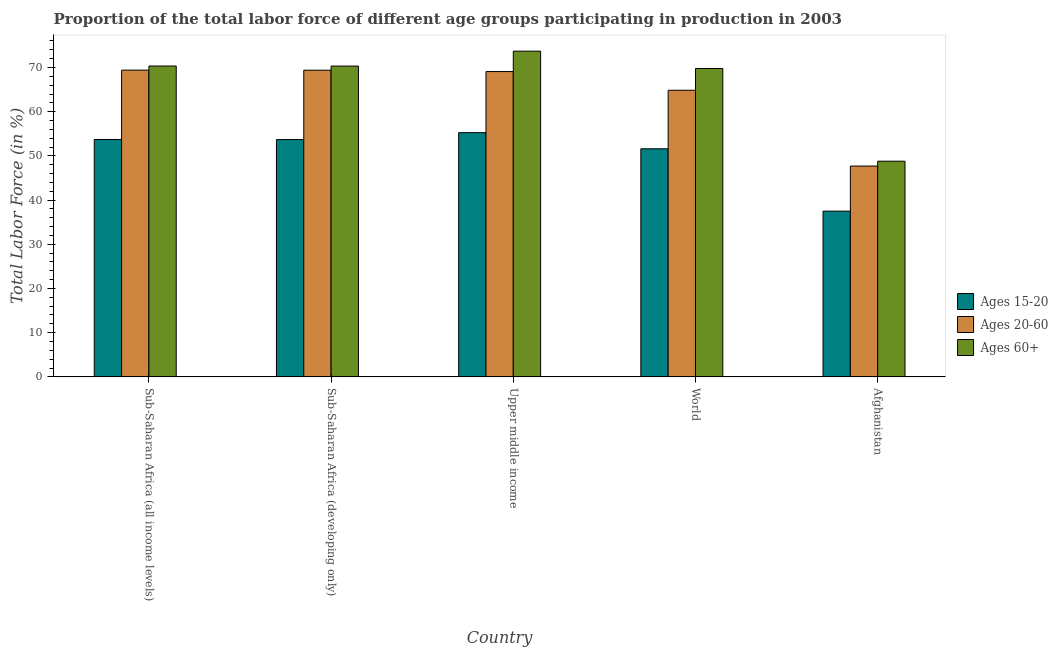How many groups of bars are there?
Your answer should be compact. 5. Are the number of bars on each tick of the X-axis equal?
Offer a very short reply. Yes. How many bars are there on the 5th tick from the left?
Ensure brevity in your answer.  3. What is the label of the 4th group of bars from the left?
Keep it short and to the point. World. In how many cases, is the number of bars for a given country not equal to the number of legend labels?
Provide a succinct answer. 0. What is the percentage of labor force within the age group 20-60 in Afghanistan?
Offer a very short reply. 47.7. Across all countries, what is the maximum percentage of labor force above age 60?
Make the answer very short. 73.7. Across all countries, what is the minimum percentage of labor force within the age group 20-60?
Ensure brevity in your answer.  47.7. In which country was the percentage of labor force within the age group 20-60 maximum?
Give a very brief answer. Sub-Saharan Africa (all income levels). In which country was the percentage of labor force within the age group 15-20 minimum?
Provide a short and direct response. Afghanistan. What is the total percentage of labor force within the age group 20-60 in the graph?
Your answer should be very brief. 320.43. What is the difference between the percentage of labor force within the age group 15-20 in Sub-Saharan Africa (developing only) and that in World?
Your answer should be very brief. 2.09. What is the difference between the percentage of labor force within the age group 20-60 in Sub-Saharan Africa (developing only) and the percentage of labor force above age 60 in Upper middle income?
Give a very brief answer. -4.31. What is the average percentage of labor force within the age group 20-60 per country?
Provide a succinct answer. 64.09. What is the difference between the percentage of labor force within the age group 15-20 and percentage of labor force above age 60 in World?
Keep it short and to the point. -18.17. In how many countries, is the percentage of labor force above age 60 greater than 58 %?
Keep it short and to the point. 4. What is the ratio of the percentage of labor force within the age group 15-20 in Afghanistan to that in World?
Keep it short and to the point. 0.73. Is the difference between the percentage of labor force above age 60 in Sub-Saharan Africa (developing only) and World greater than the difference between the percentage of labor force within the age group 15-20 in Sub-Saharan Africa (developing only) and World?
Your answer should be compact. No. What is the difference between the highest and the second highest percentage of labor force within the age group 20-60?
Make the answer very short. 0.01. What is the difference between the highest and the lowest percentage of labor force above age 60?
Offer a terse response. 24.9. In how many countries, is the percentage of labor force within the age group 20-60 greater than the average percentage of labor force within the age group 20-60 taken over all countries?
Offer a terse response. 4. Is the sum of the percentage of labor force within the age group 20-60 in Sub-Saharan Africa (all income levels) and Upper middle income greater than the maximum percentage of labor force within the age group 15-20 across all countries?
Provide a short and direct response. Yes. What does the 1st bar from the left in Afghanistan represents?
Make the answer very short. Ages 15-20. What does the 3rd bar from the right in Upper middle income represents?
Give a very brief answer. Ages 15-20. How many bars are there?
Make the answer very short. 15. How many countries are there in the graph?
Your answer should be compact. 5. What is the difference between two consecutive major ticks on the Y-axis?
Your answer should be very brief. 10. Does the graph contain grids?
Offer a very short reply. No. What is the title of the graph?
Provide a short and direct response. Proportion of the total labor force of different age groups participating in production in 2003. What is the Total Labor Force (in %) of Ages 15-20 in Sub-Saharan Africa (all income levels)?
Provide a succinct answer. 53.71. What is the Total Labor Force (in %) in Ages 20-60 in Sub-Saharan Africa (all income levels)?
Make the answer very short. 69.4. What is the Total Labor Force (in %) of Ages 60+ in Sub-Saharan Africa (all income levels)?
Give a very brief answer. 70.34. What is the Total Labor Force (in %) of Ages 15-20 in Sub-Saharan Africa (developing only)?
Offer a terse response. 53.69. What is the Total Labor Force (in %) in Ages 20-60 in Sub-Saharan Africa (developing only)?
Your answer should be very brief. 69.39. What is the Total Labor Force (in %) in Ages 60+ in Sub-Saharan Africa (developing only)?
Offer a terse response. 70.32. What is the Total Labor Force (in %) in Ages 15-20 in Upper middle income?
Provide a short and direct response. 55.26. What is the Total Labor Force (in %) in Ages 20-60 in Upper middle income?
Ensure brevity in your answer.  69.08. What is the Total Labor Force (in %) of Ages 60+ in Upper middle income?
Ensure brevity in your answer.  73.7. What is the Total Labor Force (in %) of Ages 15-20 in World?
Offer a terse response. 51.61. What is the Total Labor Force (in %) in Ages 20-60 in World?
Offer a very short reply. 64.85. What is the Total Labor Force (in %) of Ages 60+ in World?
Provide a succinct answer. 69.78. What is the Total Labor Force (in %) in Ages 15-20 in Afghanistan?
Offer a very short reply. 37.5. What is the Total Labor Force (in %) in Ages 20-60 in Afghanistan?
Your answer should be very brief. 47.7. What is the Total Labor Force (in %) in Ages 60+ in Afghanistan?
Your response must be concise. 48.8. Across all countries, what is the maximum Total Labor Force (in %) of Ages 15-20?
Make the answer very short. 55.26. Across all countries, what is the maximum Total Labor Force (in %) of Ages 20-60?
Provide a succinct answer. 69.4. Across all countries, what is the maximum Total Labor Force (in %) in Ages 60+?
Give a very brief answer. 73.7. Across all countries, what is the minimum Total Labor Force (in %) in Ages 15-20?
Offer a terse response. 37.5. Across all countries, what is the minimum Total Labor Force (in %) of Ages 20-60?
Give a very brief answer. 47.7. Across all countries, what is the minimum Total Labor Force (in %) of Ages 60+?
Provide a short and direct response. 48.8. What is the total Total Labor Force (in %) in Ages 15-20 in the graph?
Your answer should be very brief. 251.76. What is the total Total Labor Force (in %) of Ages 20-60 in the graph?
Your answer should be compact. 320.43. What is the total Total Labor Force (in %) in Ages 60+ in the graph?
Keep it short and to the point. 332.94. What is the difference between the Total Labor Force (in %) in Ages 15-20 in Sub-Saharan Africa (all income levels) and that in Sub-Saharan Africa (developing only)?
Provide a short and direct response. 0.02. What is the difference between the Total Labor Force (in %) in Ages 20-60 in Sub-Saharan Africa (all income levels) and that in Sub-Saharan Africa (developing only)?
Give a very brief answer. 0.01. What is the difference between the Total Labor Force (in %) of Ages 60+ in Sub-Saharan Africa (all income levels) and that in Sub-Saharan Africa (developing only)?
Make the answer very short. 0.02. What is the difference between the Total Labor Force (in %) in Ages 15-20 in Sub-Saharan Africa (all income levels) and that in Upper middle income?
Provide a succinct answer. -1.55. What is the difference between the Total Labor Force (in %) in Ages 20-60 in Sub-Saharan Africa (all income levels) and that in Upper middle income?
Ensure brevity in your answer.  0.32. What is the difference between the Total Labor Force (in %) of Ages 60+ in Sub-Saharan Africa (all income levels) and that in Upper middle income?
Give a very brief answer. -3.36. What is the difference between the Total Labor Force (in %) in Ages 15-20 in Sub-Saharan Africa (all income levels) and that in World?
Keep it short and to the point. 2.1. What is the difference between the Total Labor Force (in %) in Ages 20-60 in Sub-Saharan Africa (all income levels) and that in World?
Ensure brevity in your answer.  4.55. What is the difference between the Total Labor Force (in %) in Ages 60+ in Sub-Saharan Africa (all income levels) and that in World?
Offer a terse response. 0.56. What is the difference between the Total Labor Force (in %) of Ages 15-20 in Sub-Saharan Africa (all income levels) and that in Afghanistan?
Provide a succinct answer. 16.21. What is the difference between the Total Labor Force (in %) in Ages 20-60 in Sub-Saharan Africa (all income levels) and that in Afghanistan?
Ensure brevity in your answer.  21.7. What is the difference between the Total Labor Force (in %) of Ages 60+ in Sub-Saharan Africa (all income levels) and that in Afghanistan?
Provide a short and direct response. 21.54. What is the difference between the Total Labor Force (in %) of Ages 15-20 in Sub-Saharan Africa (developing only) and that in Upper middle income?
Make the answer very short. -1.56. What is the difference between the Total Labor Force (in %) in Ages 20-60 in Sub-Saharan Africa (developing only) and that in Upper middle income?
Your answer should be very brief. 0.31. What is the difference between the Total Labor Force (in %) of Ages 60+ in Sub-Saharan Africa (developing only) and that in Upper middle income?
Give a very brief answer. -3.37. What is the difference between the Total Labor Force (in %) in Ages 15-20 in Sub-Saharan Africa (developing only) and that in World?
Offer a very short reply. 2.09. What is the difference between the Total Labor Force (in %) of Ages 20-60 in Sub-Saharan Africa (developing only) and that in World?
Give a very brief answer. 4.54. What is the difference between the Total Labor Force (in %) in Ages 60+ in Sub-Saharan Africa (developing only) and that in World?
Make the answer very short. 0.54. What is the difference between the Total Labor Force (in %) in Ages 15-20 in Sub-Saharan Africa (developing only) and that in Afghanistan?
Ensure brevity in your answer.  16.19. What is the difference between the Total Labor Force (in %) in Ages 20-60 in Sub-Saharan Africa (developing only) and that in Afghanistan?
Ensure brevity in your answer.  21.69. What is the difference between the Total Labor Force (in %) of Ages 60+ in Sub-Saharan Africa (developing only) and that in Afghanistan?
Give a very brief answer. 21.52. What is the difference between the Total Labor Force (in %) in Ages 15-20 in Upper middle income and that in World?
Ensure brevity in your answer.  3.65. What is the difference between the Total Labor Force (in %) of Ages 20-60 in Upper middle income and that in World?
Your answer should be compact. 4.23. What is the difference between the Total Labor Force (in %) in Ages 60+ in Upper middle income and that in World?
Provide a short and direct response. 3.92. What is the difference between the Total Labor Force (in %) in Ages 15-20 in Upper middle income and that in Afghanistan?
Give a very brief answer. 17.76. What is the difference between the Total Labor Force (in %) of Ages 20-60 in Upper middle income and that in Afghanistan?
Provide a succinct answer. 21.38. What is the difference between the Total Labor Force (in %) of Ages 60+ in Upper middle income and that in Afghanistan?
Provide a short and direct response. 24.9. What is the difference between the Total Labor Force (in %) of Ages 15-20 in World and that in Afghanistan?
Ensure brevity in your answer.  14.11. What is the difference between the Total Labor Force (in %) of Ages 20-60 in World and that in Afghanistan?
Keep it short and to the point. 17.15. What is the difference between the Total Labor Force (in %) of Ages 60+ in World and that in Afghanistan?
Offer a terse response. 20.98. What is the difference between the Total Labor Force (in %) of Ages 15-20 in Sub-Saharan Africa (all income levels) and the Total Labor Force (in %) of Ages 20-60 in Sub-Saharan Africa (developing only)?
Ensure brevity in your answer.  -15.68. What is the difference between the Total Labor Force (in %) of Ages 15-20 in Sub-Saharan Africa (all income levels) and the Total Labor Force (in %) of Ages 60+ in Sub-Saharan Africa (developing only)?
Offer a terse response. -16.61. What is the difference between the Total Labor Force (in %) of Ages 20-60 in Sub-Saharan Africa (all income levels) and the Total Labor Force (in %) of Ages 60+ in Sub-Saharan Africa (developing only)?
Make the answer very short. -0.92. What is the difference between the Total Labor Force (in %) in Ages 15-20 in Sub-Saharan Africa (all income levels) and the Total Labor Force (in %) in Ages 20-60 in Upper middle income?
Keep it short and to the point. -15.38. What is the difference between the Total Labor Force (in %) in Ages 15-20 in Sub-Saharan Africa (all income levels) and the Total Labor Force (in %) in Ages 60+ in Upper middle income?
Offer a terse response. -19.99. What is the difference between the Total Labor Force (in %) in Ages 20-60 in Sub-Saharan Africa (all income levels) and the Total Labor Force (in %) in Ages 60+ in Upper middle income?
Your answer should be very brief. -4.29. What is the difference between the Total Labor Force (in %) in Ages 15-20 in Sub-Saharan Africa (all income levels) and the Total Labor Force (in %) in Ages 20-60 in World?
Make the answer very short. -11.14. What is the difference between the Total Labor Force (in %) in Ages 15-20 in Sub-Saharan Africa (all income levels) and the Total Labor Force (in %) in Ages 60+ in World?
Offer a very short reply. -16.07. What is the difference between the Total Labor Force (in %) of Ages 20-60 in Sub-Saharan Africa (all income levels) and the Total Labor Force (in %) of Ages 60+ in World?
Offer a very short reply. -0.37. What is the difference between the Total Labor Force (in %) of Ages 15-20 in Sub-Saharan Africa (all income levels) and the Total Labor Force (in %) of Ages 20-60 in Afghanistan?
Offer a very short reply. 6.01. What is the difference between the Total Labor Force (in %) in Ages 15-20 in Sub-Saharan Africa (all income levels) and the Total Labor Force (in %) in Ages 60+ in Afghanistan?
Your response must be concise. 4.91. What is the difference between the Total Labor Force (in %) in Ages 20-60 in Sub-Saharan Africa (all income levels) and the Total Labor Force (in %) in Ages 60+ in Afghanistan?
Your response must be concise. 20.6. What is the difference between the Total Labor Force (in %) in Ages 15-20 in Sub-Saharan Africa (developing only) and the Total Labor Force (in %) in Ages 20-60 in Upper middle income?
Offer a terse response. -15.39. What is the difference between the Total Labor Force (in %) of Ages 15-20 in Sub-Saharan Africa (developing only) and the Total Labor Force (in %) of Ages 60+ in Upper middle income?
Keep it short and to the point. -20. What is the difference between the Total Labor Force (in %) of Ages 20-60 in Sub-Saharan Africa (developing only) and the Total Labor Force (in %) of Ages 60+ in Upper middle income?
Offer a terse response. -4.31. What is the difference between the Total Labor Force (in %) of Ages 15-20 in Sub-Saharan Africa (developing only) and the Total Labor Force (in %) of Ages 20-60 in World?
Your response must be concise. -11.16. What is the difference between the Total Labor Force (in %) in Ages 15-20 in Sub-Saharan Africa (developing only) and the Total Labor Force (in %) in Ages 60+ in World?
Make the answer very short. -16.09. What is the difference between the Total Labor Force (in %) of Ages 20-60 in Sub-Saharan Africa (developing only) and the Total Labor Force (in %) of Ages 60+ in World?
Offer a very short reply. -0.39. What is the difference between the Total Labor Force (in %) of Ages 15-20 in Sub-Saharan Africa (developing only) and the Total Labor Force (in %) of Ages 20-60 in Afghanistan?
Provide a succinct answer. 5.99. What is the difference between the Total Labor Force (in %) of Ages 15-20 in Sub-Saharan Africa (developing only) and the Total Labor Force (in %) of Ages 60+ in Afghanistan?
Your answer should be very brief. 4.89. What is the difference between the Total Labor Force (in %) of Ages 20-60 in Sub-Saharan Africa (developing only) and the Total Labor Force (in %) of Ages 60+ in Afghanistan?
Offer a terse response. 20.59. What is the difference between the Total Labor Force (in %) of Ages 15-20 in Upper middle income and the Total Labor Force (in %) of Ages 20-60 in World?
Your answer should be very brief. -9.6. What is the difference between the Total Labor Force (in %) in Ages 15-20 in Upper middle income and the Total Labor Force (in %) in Ages 60+ in World?
Your answer should be compact. -14.52. What is the difference between the Total Labor Force (in %) of Ages 20-60 in Upper middle income and the Total Labor Force (in %) of Ages 60+ in World?
Ensure brevity in your answer.  -0.7. What is the difference between the Total Labor Force (in %) in Ages 15-20 in Upper middle income and the Total Labor Force (in %) in Ages 20-60 in Afghanistan?
Your response must be concise. 7.56. What is the difference between the Total Labor Force (in %) in Ages 15-20 in Upper middle income and the Total Labor Force (in %) in Ages 60+ in Afghanistan?
Your answer should be compact. 6.46. What is the difference between the Total Labor Force (in %) of Ages 20-60 in Upper middle income and the Total Labor Force (in %) of Ages 60+ in Afghanistan?
Your answer should be very brief. 20.28. What is the difference between the Total Labor Force (in %) in Ages 15-20 in World and the Total Labor Force (in %) in Ages 20-60 in Afghanistan?
Make the answer very short. 3.91. What is the difference between the Total Labor Force (in %) of Ages 15-20 in World and the Total Labor Force (in %) of Ages 60+ in Afghanistan?
Ensure brevity in your answer.  2.81. What is the difference between the Total Labor Force (in %) of Ages 20-60 in World and the Total Labor Force (in %) of Ages 60+ in Afghanistan?
Provide a succinct answer. 16.05. What is the average Total Labor Force (in %) of Ages 15-20 per country?
Give a very brief answer. 50.35. What is the average Total Labor Force (in %) in Ages 20-60 per country?
Ensure brevity in your answer.  64.09. What is the average Total Labor Force (in %) of Ages 60+ per country?
Your answer should be compact. 66.59. What is the difference between the Total Labor Force (in %) of Ages 15-20 and Total Labor Force (in %) of Ages 20-60 in Sub-Saharan Africa (all income levels)?
Provide a short and direct response. -15.7. What is the difference between the Total Labor Force (in %) in Ages 15-20 and Total Labor Force (in %) in Ages 60+ in Sub-Saharan Africa (all income levels)?
Provide a short and direct response. -16.63. What is the difference between the Total Labor Force (in %) of Ages 20-60 and Total Labor Force (in %) of Ages 60+ in Sub-Saharan Africa (all income levels)?
Provide a succinct answer. -0.93. What is the difference between the Total Labor Force (in %) in Ages 15-20 and Total Labor Force (in %) in Ages 20-60 in Sub-Saharan Africa (developing only)?
Your response must be concise. -15.7. What is the difference between the Total Labor Force (in %) of Ages 15-20 and Total Labor Force (in %) of Ages 60+ in Sub-Saharan Africa (developing only)?
Offer a terse response. -16.63. What is the difference between the Total Labor Force (in %) of Ages 20-60 and Total Labor Force (in %) of Ages 60+ in Sub-Saharan Africa (developing only)?
Give a very brief answer. -0.93. What is the difference between the Total Labor Force (in %) in Ages 15-20 and Total Labor Force (in %) in Ages 20-60 in Upper middle income?
Your answer should be very brief. -13.83. What is the difference between the Total Labor Force (in %) in Ages 15-20 and Total Labor Force (in %) in Ages 60+ in Upper middle income?
Offer a very short reply. -18.44. What is the difference between the Total Labor Force (in %) of Ages 20-60 and Total Labor Force (in %) of Ages 60+ in Upper middle income?
Ensure brevity in your answer.  -4.61. What is the difference between the Total Labor Force (in %) of Ages 15-20 and Total Labor Force (in %) of Ages 20-60 in World?
Provide a short and direct response. -13.24. What is the difference between the Total Labor Force (in %) of Ages 15-20 and Total Labor Force (in %) of Ages 60+ in World?
Your response must be concise. -18.17. What is the difference between the Total Labor Force (in %) of Ages 20-60 and Total Labor Force (in %) of Ages 60+ in World?
Give a very brief answer. -4.93. What is the difference between the Total Labor Force (in %) in Ages 15-20 and Total Labor Force (in %) in Ages 20-60 in Afghanistan?
Give a very brief answer. -10.2. What is the difference between the Total Labor Force (in %) of Ages 15-20 and Total Labor Force (in %) of Ages 60+ in Afghanistan?
Your answer should be compact. -11.3. What is the difference between the Total Labor Force (in %) in Ages 20-60 and Total Labor Force (in %) in Ages 60+ in Afghanistan?
Provide a succinct answer. -1.1. What is the ratio of the Total Labor Force (in %) in Ages 60+ in Sub-Saharan Africa (all income levels) to that in Sub-Saharan Africa (developing only)?
Your answer should be compact. 1. What is the ratio of the Total Labor Force (in %) of Ages 60+ in Sub-Saharan Africa (all income levels) to that in Upper middle income?
Give a very brief answer. 0.95. What is the ratio of the Total Labor Force (in %) in Ages 15-20 in Sub-Saharan Africa (all income levels) to that in World?
Ensure brevity in your answer.  1.04. What is the ratio of the Total Labor Force (in %) of Ages 20-60 in Sub-Saharan Africa (all income levels) to that in World?
Make the answer very short. 1.07. What is the ratio of the Total Labor Force (in %) of Ages 60+ in Sub-Saharan Africa (all income levels) to that in World?
Provide a short and direct response. 1.01. What is the ratio of the Total Labor Force (in %) in Ages 15-20 in Sub-Saharan Africa (all income levels) to that in Afghanistan?
Provide a succinct answer. 1.43. What is the ratio of the Total Labor Force (in %) of Ages 20-60 in Sub-Saharan Africa (all income levels) to that in Afghanistan?
Your answer should be compact. 1.46. What is the ratio of the Total Labor Force (in %) of Ages 60+ in Sub-Saharan Africa (all income levels) to that in Afghanistan?
Provide a succinct answer. 1.44. What is the ratio of the Total Labor Force (in %) of Ages 15-20 in Sub-Saharan Africa (developing only) to that in Upper middle income?
Give a very brief answer. 0.97. What is the ratio of the Total Labor Force (in %) in Ages 60+ in Sub-Saharan Africa (developing only) to that in Upper middle income?
Offer a terse response. 0.95. What is the ratio of the Total Labor Force (in %) of Ages 15-20 in Sub-Saharan Africa (developing only) to that in World?
Ensure brevity in your answer.  1.04. What is the ratio of the Total Labor Force (in %) in Ages 20-60 in Sub-Saharan Africa (developing only) to that in World?
Give a very brief answer. 1.07. What is the ratio of the Total Labor Force (in %) in Ages 60+ in Sub-Saharan Africa (developing only) to that in World?
Make the answer very short. 1.01. What is the ratio of the Total Labor Force (in %) in Ages 15-20 in Sub-Saharan Africa (developing only) to that in Afghanistan?
Offer a very short reply. 1.43. What is the ratio of the Total Labor Force (in %) of Ages 20-60 in Sub-Saharan Africa (developing only) to that in Afghanistan?
Keep it short and to the point. 1.45. What is the ratio of the Total Labor Force (in %) in Ages 60+ in Sub-Saharan Africa (developing only) to that in Afghanistan?
Offer a very short reply. 1.44. What is the ratio of the Total Labor Force (in %) in Ages 15-20 in Upper middle income to that in World?
Offer a very short reply. 1.07. What is the ratio of the Total Labor Force (in %) of Ages 20-60 in Upper middle income to that in World?
Keep it short and to the point. 1.07. What is the ratio of the Total Labor Force (in %) of Ages 60+ in Upper middle income to that in World?
Offer a terse response. 1.06. What is the ratio of the Total Labor Force (in %) of Ages 15-20 in Upper middle income to that in Afghanistan?
Provide a short and direct response. 1.47. What is the ratio of the Total Labor Force (in %) in Ages 20-60 in Upper middle income to that in Afghanistan?
Ensure brevity in your answer.  1.45. What is the ratio of the Total Labor Force (in %) of Ages 60+ in Upper middle income to that in Afghanistan?
Your response must be concise. 1.51. What is the ratio of the Total Labor Force (in %) of Ages 15-20 in World to that in Afghanistan?
Keep it short and to the point. 1.38. What is the ratio of the Total Labor Force (in %) of Ages 20-60 in World to that in Afghanistan?
Keep it short and to the point. 1.36. What is the ratio of the Total Labor Force (in %) in Ages 60+ in World to that in Afghanistan?
Give a very brief answer. 1.43. What is the difference between the highest and the second highest Total Labor Force (in %) in Ages 15-20?
Provide a succinct answer. 1.55. What is the difference between the highest and the second highest Total Labor Force (in %) of Ages 20-60?
Offer a terse response. 0.01. What is the difference between the highest and the second highest Total Labor Force (in %) in Ages 60+?
Your answer should be very brief. 3.36. What is the difference between the highest and the lowest Total Labor Force (in %) in Ages 15-20?
Your response must be concise. 17.76. What is the difference between the highest and the lowest Total Labor Force (in %) of Ages 20-60?
Give a very brief answer. 21.7. What is the difference between the highest and the lowest Total Labor Force (in %) in Ages 60+?
Your response must be concise. 24.9. 